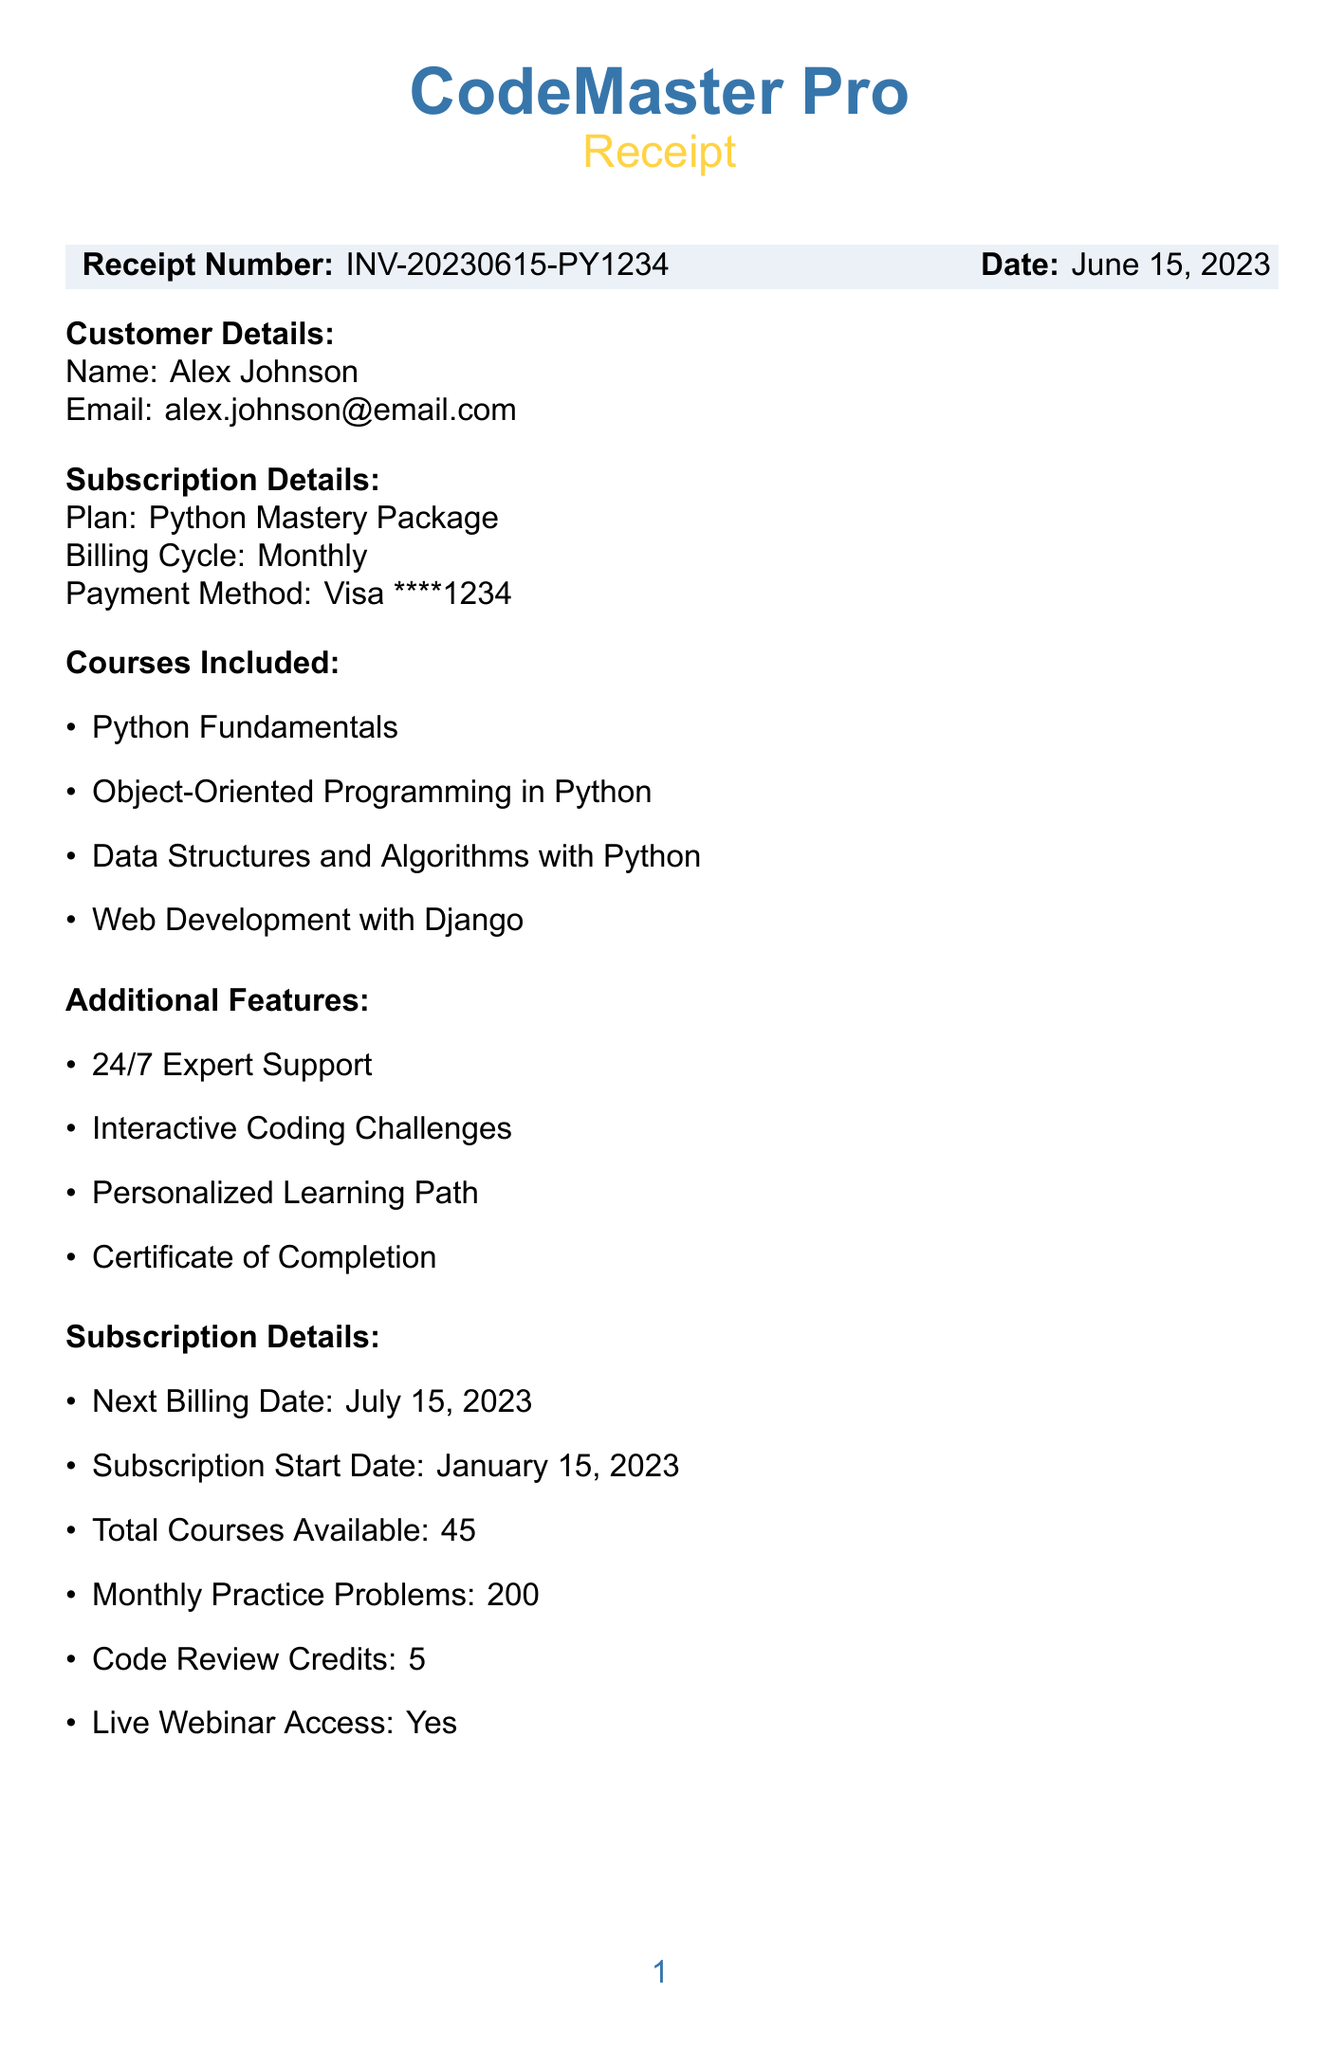What is the receipt number? The receipt number is clearly stated in the document, which is INV-20230615-PY1234.
Answer: INV-20230615-PY1234 Who is the customer? The customer's name appears at the top of the document, which is Alex Johnson.
Answer: Alex Johnson What is the monthly fee? The monthly fee is listed in the billing summary of the document, which is $49.99.
Answer: $49.99 What discount was applied? The discount applied is mentioned in the billing summary as 10% off for Python Tutors.
Answer: 10% off for Python Tutors When is the next billing date? The document specifies the next billing date, which is July 15, 2023.
Answer: July 15, 2023 How many courses are included in the subscription? The number of courses included is detailed in the subscription section, which includes 4 specific courses listed.
Answer: 4 What additional features are offered? The document outlines several features, including "24/7 Expert Support", "Interactive Coding Challenges", "Personalized Learning Path", and "Certificate of Completion".
Answer: 24/7 Expert Support, Interactive Coding Challenges, Personalized Learning Path, Certificate of Completion What is the total charged amount? The total charged amount is stated in the billing summary as $48.59.
Answer: $48.59 Is live webinar access included? The document confirms that live webinar access is included as "Yes" in the subscription details.
Answer: Yes 